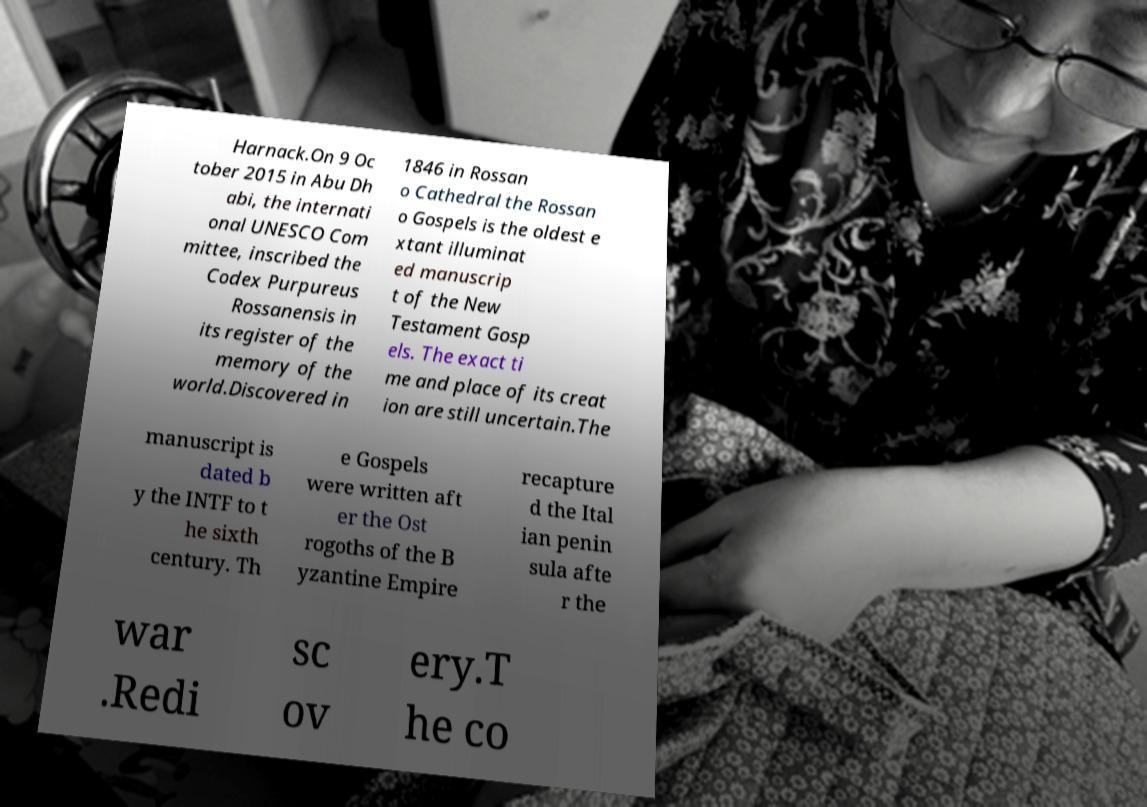Could you extract and type out the text from this image? Harnack.On 9 Oc tober 2015 in Abu Dh abi, the internati onal UNESCO Com mittee, inscribed the Codex Purpureus Rossanensis in its register of the memory of the world.Discovered in 1846 in Rossan o Cathedral the Rossan o Gospels is the oldest e xtant illuminat ed manuscrip t of the New Testament Gosp els. The exact ti me and place of its creat ion are still uncertain.The manuscript is dated b y the INTF to t he sixth century. Th e Gospels were written aft er the Ost rogoths of the B yzantine Empire recapture d the Ital ian penin sula afte r the war .Redi sc ov ery.T he co 